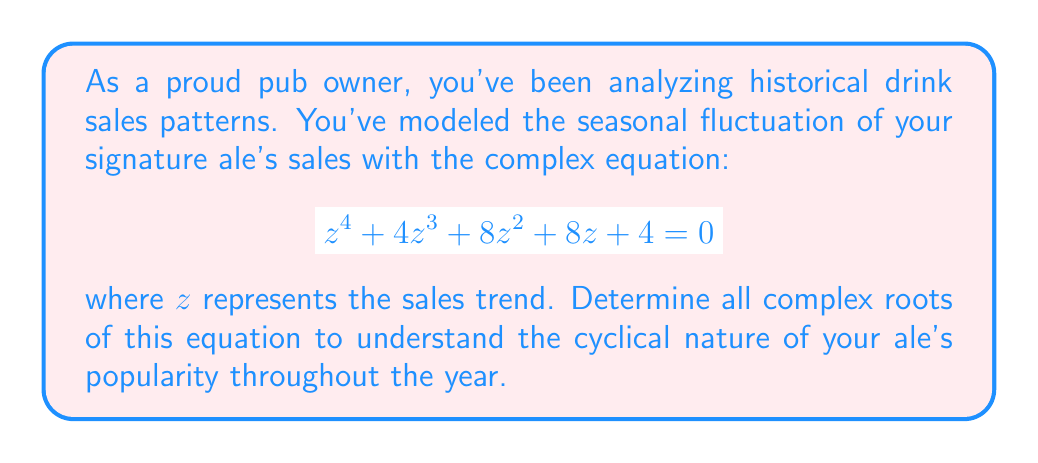What is the answer to this math problem? To solve this complex equation, we'll use the following steps:

1) First, notice that this equation has the form of a depressed quartic equation:

   $$ z^4 + pz^3 + qz^2 + rz + s = 0 $$

   where $p=4$, $q=8$, $r=8$, and $s=4$.

2) We can factor this equation as:

   $$ (z^2 + 2z + 2)^2 = 0 $$

3) This means we need to solve:

   $$ z^2 + 2z + 2 = 0 $$

4) This is a quadratic equation. We can solve it using the quadratic formula:

   $$ z = \frac{-b \pm \sqrt{b^2 - 4ac}}{2a} $$

   where $a=1$, $b=2$, and $c=2$.

5) Substituting these values:

   $$ z = \frac{-2 \pm \sqrt{2^2 - 4(1)(2)}}{2(1)} = \frac{-2 \pm \sqrt{4 - 8}}{2} = \frac{-2 \pm \sqrt{-4}}{2} $$

6) Simplify:

   $$ z = \frac{-2 \pm 2i}{2} = -1 \pm i $$

7) Therefore, the two roots are:

   $$ z_1 = -1 + i \quad \text{and} \quad z_2 = -1 - i $$

8) Since the original equation was $(z^2 + 2z + 2)^2 = 0$, each of these roots has a multiplicity of 2.

Thus, the four complex roots of the equation are: $-1+i$ (twice) and $-1-i$ (twice).
Answer: The complex roots are: $-1+i$ (with multiplicity 2) and $-1-i$ (with multiplicity 2). 